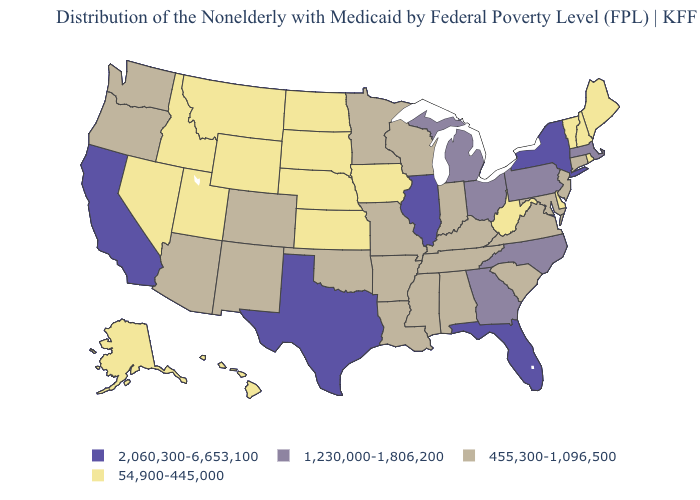Among the states that border Georgia , does Florida have the highest value?
Concise answer only. Yes. Does the first symbol in the legend represent the smallest category?
Give a very brief answer. No. What is the value of Wyoming?
Be succinct. 54,900-445,000. What is the highest value in the USA?
Keep it brief. 2,060,300-6,653,100. Does New Hampshire have a lower value than Louisiana?
Keep it brief. Yes. What is the value of Arizona?
Be succinct. 455,300-1,096,500. Name the states that have a value in the range 2,060,300-6,653,100?
Write a very short answer. California, Florida, Illinois, New York, Texas. What is the highest value in states that border Utah?
Keep it brief. 455,300-1,096,500. Is the legend a continuous bar?
Concise answer only. No. What is the value of Kansas?
Short answer required. 54,900-445,000. Name the states that have a value in the range 455,300-1,096,500?
Short answer required. Alabama, Arizona, Arkansas, Colorado, Connecticut, Indiana, Kentucky, Louisiana, Maryland, Minnesota, Mississippi, Missouri, New Jersey, New Mexico, Oklahoma, Oregon, South Carolina, Tennessee, Virginia, Washington, Wisconsin. Does the first symbol in the legend represent the smallest category?
Write a very short answer. No. What is the lowest value in the MidWest?
Quick response, please. 54,900-445,000. Name the states that have a value in the range 1,230,000-1,806,200?
Give a very brief answer. Georgia, Massachusetts, Michigan, North Carolina, Ohio, Pennsylvania. Does the first symbol in the legend represent the smallest category?
Keep it brief. No. 